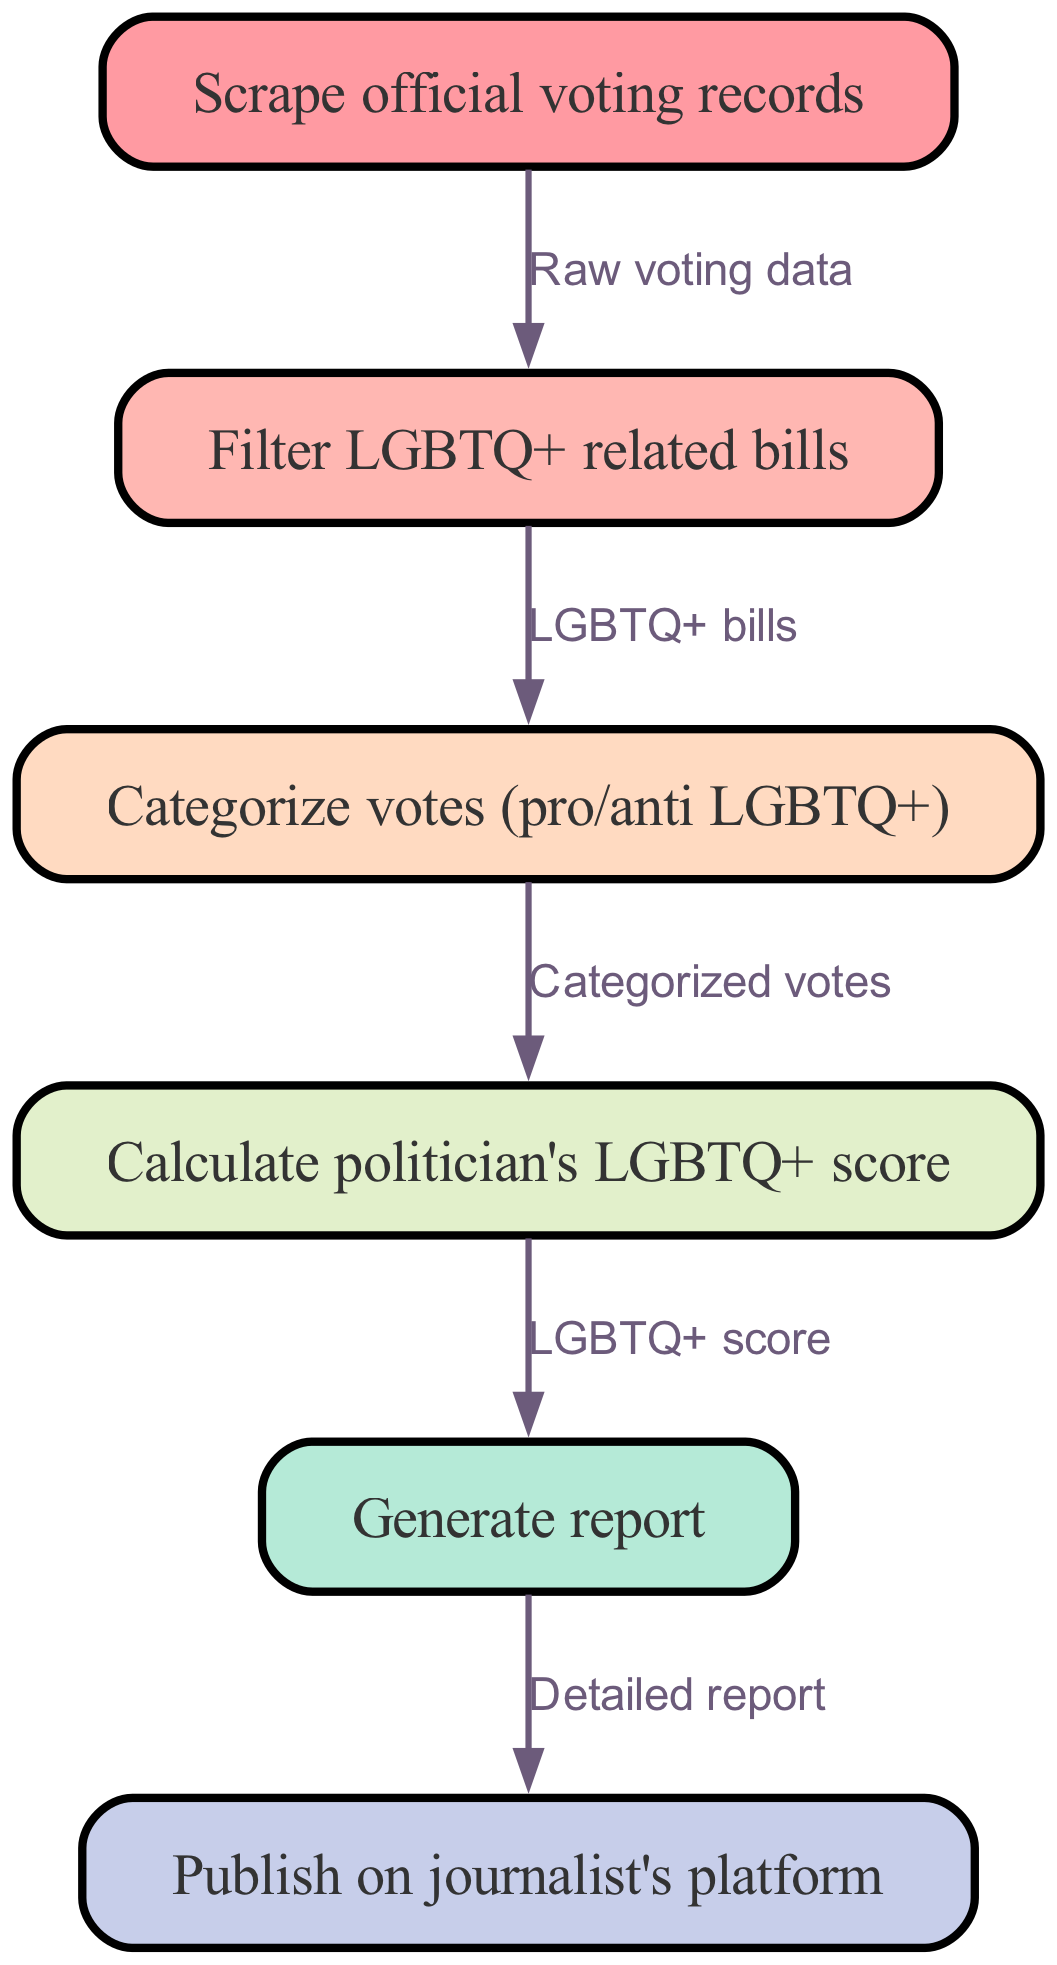What is the first step in the flowchart? The first step in the flowchart is "Scrape official voting records," which is represented as the starting node.
Answer: Scrape official voting records How many nodes are present in the diagram? By counting the nodes listed in the diagram, there are a total of six nodes.
Answer: 6 What type of records do you filter in the second step? The second step involves filtering for "LGBTQ+ related bills," as indicated by the node directly connected to it.
Answer: LGBTQ+ related bills What is calculated in the fourth step of the diagram? In the fourth step, the process involves calculating the "politician's LGBTQ+ score," which is an evaluation of the politician's voting history.
Answer: politician's LGBTQ+ score What is the connection between the third and fourth nodes? The third node, which categorizes votes as pro or anti LGBTQ+, connects to the fourth node that calculates the LGBTQ+ score, indicating a logical progression from categorization to scoring.
Answer: Categorized votes Which node directly leads to the publishing action? The node "Generate report" leads directly to the action of publishing on the journalist's platform as the final step in the flowchart.
Answer: Generate report How does the flow begin according to the diagram? The flow begins with the action of scraping voting records, which serves as the initial input to the automated system.
Answer: Scrape official voting records What is the output generated in the last step? The final step of the process generates a "Detailed report," summarizing the findings of the previous steps.
Answer: Detailed report 